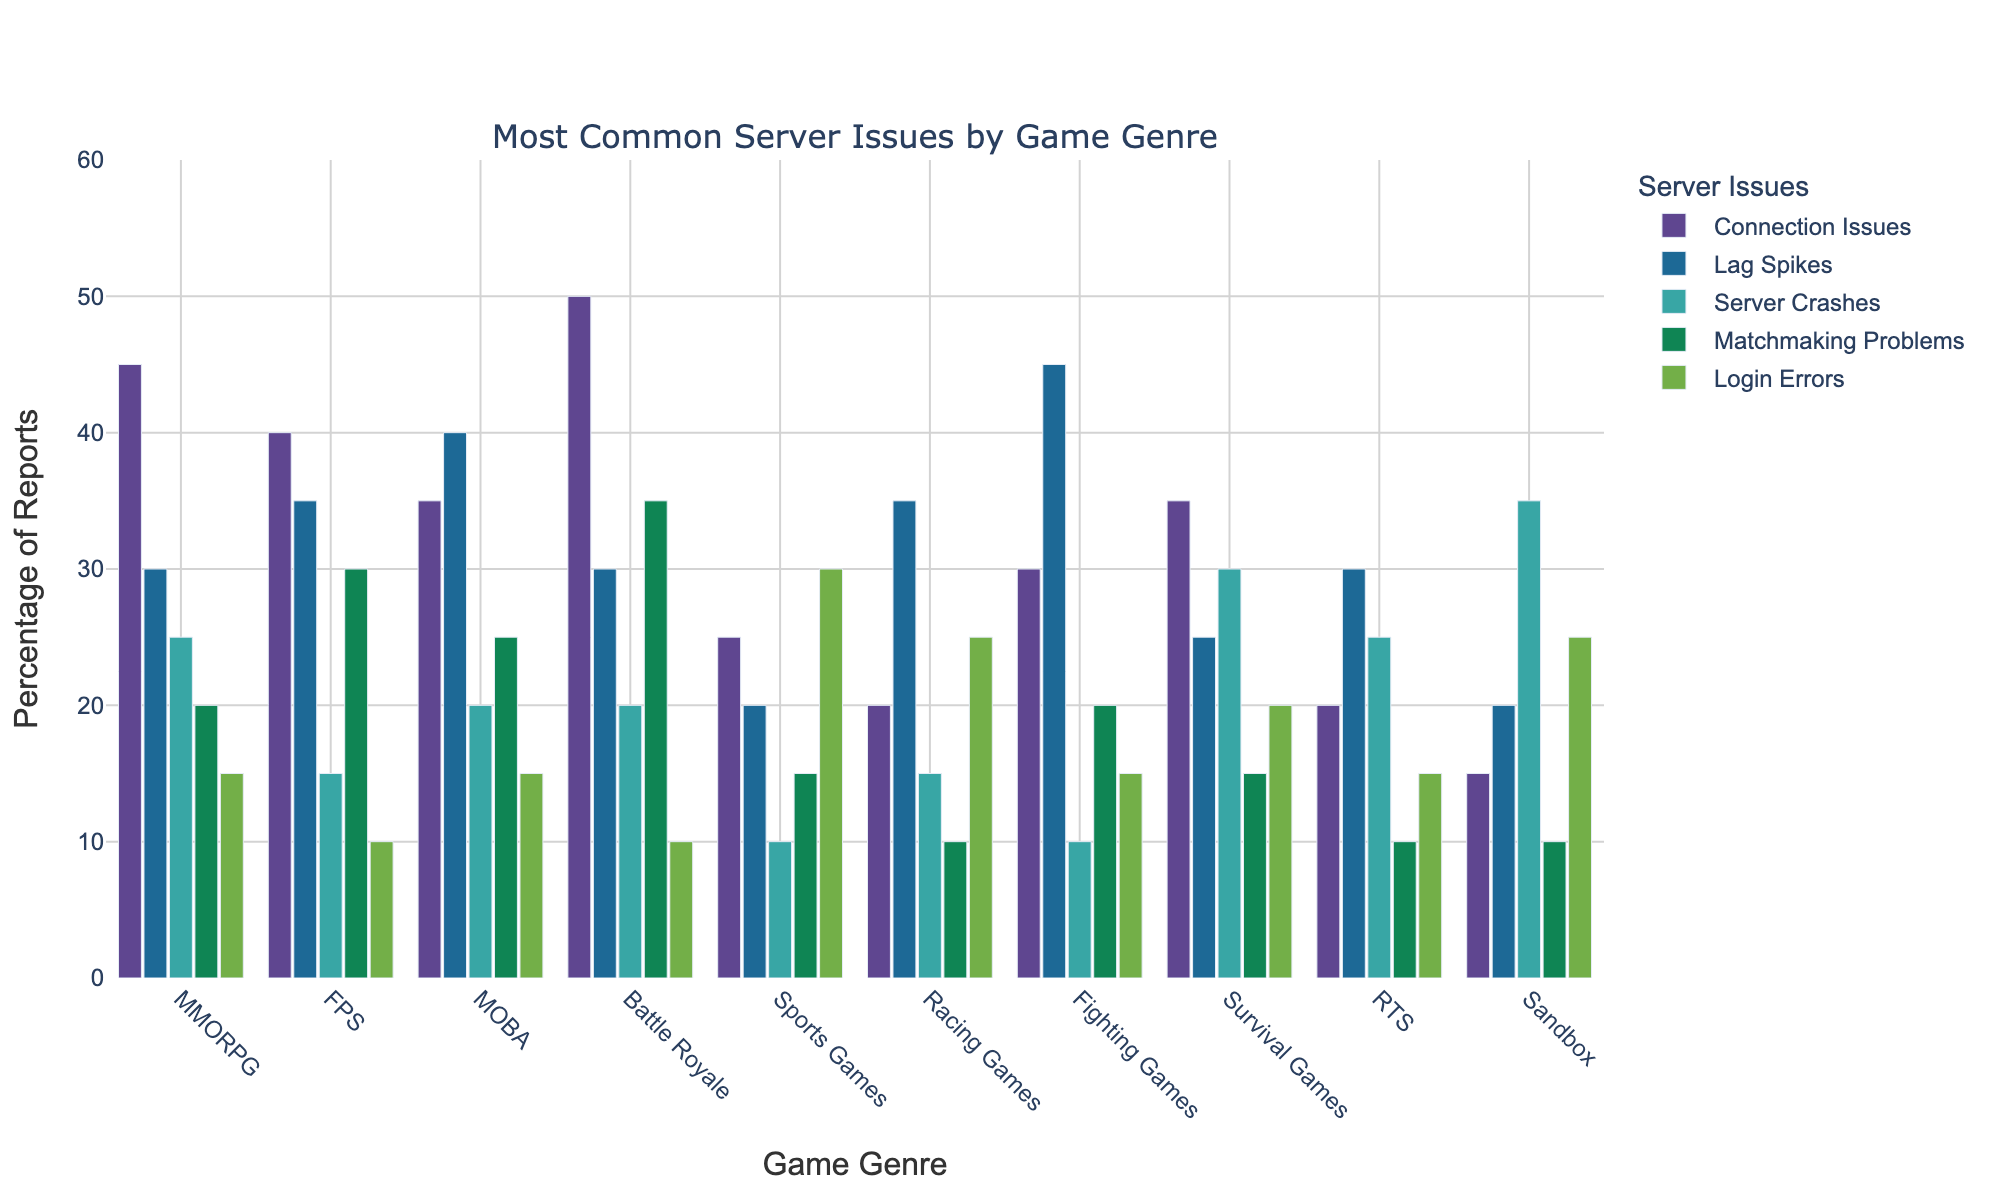What is the most reported server issue for MMORPGs? Look at the bar corresponding to the MMORPG genre and find the highest bar. Connection Issues has the highest bar, indicating it is the most reported issue.
Answer: Connection Issues Which genre reports the most Login Errors? Compare the heights of the bars representing Login Errors across all genres. Sports Games has the tallest bar for Login Errors.
Answer: Sports Games How many total Matchmaking Problems are reported for all genres combined? Sum the values of Matchmaking Problems for all genres: 20 (MMORPG) + 30 (FPS) + 25 (MOBA) + 35 (Battle Royale) + 15 (Sports Games) + 10 (Racing Games) + 20 (Fighting Games) + 15 (Survival Games) + 10 (RTS) + 10 (Sandbox) = 190.
Answer: 190 Which genre experiences fewer Lag Spikes than Racing Games? Compare the height of the Lag Spikes bar for Racing Games to other genres. Genres with lower bars are MMORPG (30), Battle Royale (30), Survival Games (25), Sandbox (20), and Sports Games (20).
Answer: MMORPG, Battle Royale, Survival Games, Sandbox, Sports Games What is the difference in the number of Server Crashes reported between Survival Games and Sandbox games? Look at the height of the bars representing Server Crashes for both genres. Survival Games is 30, and Sandbox is 35. The difference is 35 - 30 = 5.
Answer: 5 Which genres report an equal number of Lag Spikes and Login Errors? Look at the bars for Lag Spikes and Login Errors for each genre to find matches of equal height. Both MMORPGs and MOBAs report 15 Lag Spikes and 15 Login Errors.
Answer: MMORPG, MOBA What is the average number of Connection Issues reported across all genres? Sum the values of Connection Issues for all genres: 45 (MMORPG) + 40 (FPS) + 35 (MOBA) + 50 (Battle Royale) + 25 (Sports Games) + 20 (Racing Games) + 30 (Fighting Games) + 35 (Survival Games) + 20 (RTS) + 15 (Sandbox) = 315. Average is 315 / 10 = 31.5.
Answer: 31.5 Which issue has the lowest number of reports for FPS games? Compare the heights of the bars representing different issues for FPS games. Login Errors has the lowest bar with 10 reports.
Answer: Login Errors In how many genres are Server Crashes the most reported issue? Look for the tallest bar within each genre and count those where Server Crashes is the highest. Only in Sandbox games do Server Crashes have the tallest bar.
Answer: 1 Is the number of Connection Issues reported in Battle Royale games higher than Login Errors reported in Sports Games? Compare the heights of the bars for Connection Issues in Battle Royale (50) and Login Errors in Sports Games (30). Since 50 > 30, the statement is true.
Answer: Yes 